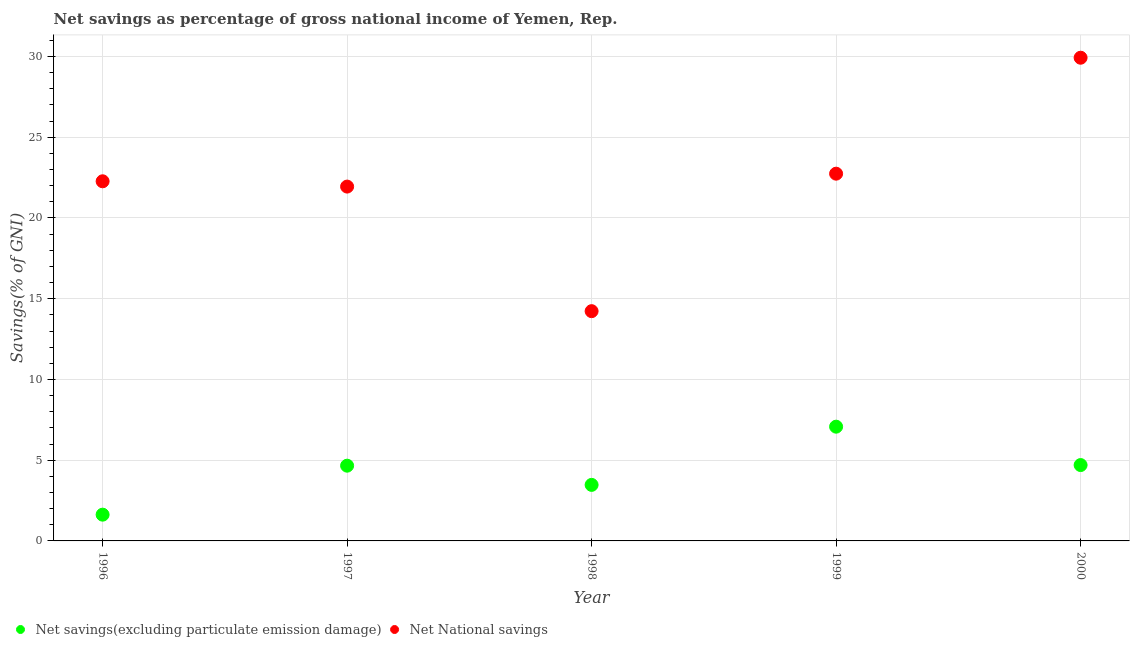Is the number of dotlines equal to the number of legend labels?
Make the answer very short. Yes. What is the net savings(excluding particulate emission damage) in 1998?
Provide a short and direct response. 3.47. Across all years, what is the maximum net savings(excluding particulate emission damage)?
Your answer should be very brief. 7.08. Across all years, what is the minimum net national savings?
Your answer should be compact. 14.23. In which year was the net savings(excluding particulate emission damage) maximum?
Provide a succinct answer. 1999. In which year was the net savings(excluding particulate emission damage) minimum?
Offer a terse response. 1996. What is the total net national savings in the graph?
Give a very brief answer. 111.11. What is the difference between the net national savings in 1996 and that in 1997?
Your response must be concise. 0.33. What is the difference between the net national savings in 1996 and the net savings(excluding particulate emission damage) in 2000?
Make the answer very short. 17.57. What is the average net national savings per year?
Provide a succinct answer. 22.22. In the year 2000, what is the difference between the net savings(excluding particulate emission damage) and net national savings?
Offer a very short reply. -25.23. What is the ratio of the net national savings in 1998 to that in 2000?
Provide a succinct answer. 0.48. Is the net savings(excluding particulate emission damage) in 1996 less than that in 2000?
Make the answer very short. Yes. Is the difference between the net savings(excluding particulate emission damage) in 1998 and 2000 greater than the difference between the net national savings in 1998 and 2000?
Make the answer very short. Yes. What is the difference between the highest and the second highest net national savings?
Make the answer very short. 7.18. What is the difference between the highest and the lowest net national savings?
Keep it short and to the point. 15.7. In how many years, is the net national savings greater than the average net national savings taken over all years?
Offer a terse response. 3. Is the net national savings strictly greater than the net savings(excluding particulate emission damage) over the years?
Make the answer very short. Yes. What is the difference between two consecutive major ticks on the Y-axis?
Keep it short and to the point. 5. Are the values on the major ticks of Y-axis written in scientific E-notation?
Your response must be concise. No. Does the graph contain any zero values?
Offer a terse response. No. Does the graph contain grids?
Your response must be concise. Yes. Where does the legend appear in the graph?
Offer a very short reply. Bottom left. What is the title of the graph?
Ensure brevity in your answer.  Net savings as percentage of gross national income of Yemen, Rep. Does "By country of asylum" appear as one of the legend labels in the graph?
Your answer should be very brief. No. What is the label or title of the Y-axis?
Your response must be concise. Savings(% of GNI). What is the Savings(% of GNI) in Net savings(excluding particulate emission damage) in 1996?
Ensure brevity in your answer.  1.63. What is the Savings(% of GNI) of Net National savings in 1996?
Ensure brevity in your answer.  22.27. What is the Savings(% of GNI) in Net savings(excluding particulate emission damage) in 1997?
Offer a very short reply. 4.66. What is the Savings(% of GNI) in Net National savings in 1997?
Give a very brief answer. 21.94. What is the Savings(% of GNI) of Net savings(excluding particulate emission damage) in 1998?
Provide a short and direct response. 3.47. What is the Savings(% of GNI) in Net National savings in 1998?
Provide a short and direct response. 14.23. What is the Savings(% of GNI) of Net savings(excluding particulate emission damage) in 1999?
Make the answer very short. 7.08. What is the Savings(% of GNI) in Net National savings in 1999?
Provide a short and direct response. 22.74. What is the Savings(% of GNI) in Net savings(excluding particulate emission damage) in 2000?
Your answer should be very brief. 4.7. What is the Savings(% of GNI) in Net National savings in 2000?
Your answer should be very brief. 29.92. Across all years, what is the maximum Savings(% of GNI) of Net savings(excluding particulate emission damage)?
Offer a terse response. 7.08. Across all years, what is the maximum Savings(% of GNI) in Net National savings?
Give a very brief answer. 29.92. Across all years, what is the minimum Savings(% of GNI) of Net savings(excluding particulate emission damage)?
Make the answer very short. 1.63. Across all years, what is the minimum Savings(% of GNI) of Net National savings?
Your response must be concise. 14.23. What is the total Savings(% of GNI) in Net savings(excluding particulate emission damage) in the graph?
Your answer should be very brief. 21.53. What is the total Savings(% of GNI) in Net National savings in the graph?
Keep it short and to the point. 111.11. What is the difference between the Savings(% of GNI) in Net savings(excluding particulate emission damage) in 1996 and that in 1997?
Offer a terse response. -3.03. What is the difference between the Savings(% of GNI) of Net National savings in 1996 and that in 1997?
Provide a short and direct response. 0.33. What is the difference between the Savings(% of GNI) in Net savings(excluding particulate emission damage) in 1996 and that in 1998?
Offer a very short reply. -1.84. What is the difference between the Savings(% of GNI) of Net National savings in 1996 and that in 1998?
Your answer should be very brief. 8.04. What is the difference between the Savings(% of GNI) of Net savings(excluding particulate emission damage) in 1996 and that in 1999?
Make the answer very short. -5.45. What is the difference between the Savings(% of GNI) of Net National savings in 1996 and that in 1999?
Keep it short and to the point. -0.47. What is the difference between the Savings(% of GNI) in Net savings(excluding particulate emission damage) in 1996 and that in 2000?
Make the answer very short. -3.07. What is the difference between the Savings(% of GNI) in Net National savings in 1996 and that in 2000?
Your answer should be compact. -7.65. What is the difference between the Savings(% of GNI) of Net savings(excluding particulate emission damage) in 1997 and that in 1998?
Keep it short and to the point. 1.19. What is the difference between the Savings(% of GNI) of Net National savings in 1997 and that in 1998?
Make the answer very short. 7.71. What is the difference between the Savings(% of GNI) of Net savings(excluding particulate emission damage) in 1997 and that in 1999?
Provide a short and direct response. -2.42. What is the difference between the Savings(% of GNI) in Net National savings in 1997 and that in 1999?
Give a very brief answer. -0.8. What is the difference between the Savings(% of GNI) in Net savings(excluding particulate emission damage) in 1997 and that in 2000?
Your answer should be compact. -0.04. What is the difference between the Savings(% of GNI) in Net National savings in 1997 and that in 2000?
Offer a terse response. -7.98. What is the difference between the Savings(% of GNI) in Net savings(excluding particulate emission damage) in 1998 and that in 1999?
Your answer should be compact. -3.6. What is the difference between the Savings(% of GNI) in Net National savings in 1998 and that in 1999?
Your answer should be compact. -8.51. What is the difference between the Savings(% of GNI) of Net savings(excluding particulate emission damage) in 1998 and that in 2000?
Your response must be concise. -1.23. What is the difference between the Savings(% of GNI) in Net National savings in 1998 and that in 2000?
Offer a very short reply. -15.7. What is the difference between the Savings(% of GNI) of Net savings(excluding particulate emission damage) in 1999 and that in 2000?
Offer a terse response. 2.38. What is the difference between the Savings(% of GNI) of Net National savings in 1999 and that in 2000?
Your answer should be very brief. -7.18. What is the difference between the Savings(% of GNI) of Net savings(excluding particulate emission damage) in 1996 and the Savings(% of GNI) of Net National savings in 1997?
Your response must be concise. -20.32. What is the difference between the Savings(% of GNI) in Net savings(excluding particulate emission damage) in 1996 and the Savings(% of GNI) in Net National savings in 1998?
Your response must be concise. -12.6. What is the difference between the Savings(% of GNI) in Net savings(excluding particulate emission damage) in 1996 and the Savings(% of GNI) in Net National savings in 1999?
Make the answer very short. -21.12. What is the difference between the Savings(% of GNI) of Net savings(excluding particulate emission damage) in 1996 and the Savings(% of GNI) of Net National savings in 2000?
Your answer should be compact. -28.3. What is the difference between the Savings(% of GNI) in Net savings(excluding particulate emission damage) in 1997 and the Savings(% of GNI) in Net National savings in 1998?
Your answer should be compact. -9.57. What is the difference between the Savings(% of GNI) in Net savings(excluding particulate emission damage) in 1997 and the Savings(% of GNI) in Net National savings in 1999?
Provide a succinct answer. -18.08. What is the difference between the Savings(% of GNI) of Net savings(excluding particulate emission damage) in 1997 and the Savings(% of GNI) of Net National savings in 2000?
Provide a succinct answer. -25.26. What is the difference between the Savings(% of GNI) in Net savings(excluding particulate emission damage) in 1998 and the Savings(% of GNI) in Net National savings in 1999?
Provide a succinct answer. -19.27. What is the difference between the Savings(% of GNI) in Net savings(excluding particulate emission damage) in 1998 and the Savings(% of GNI) in Net National savings in 2000?
Provide a short and direct response. -26.45. What is the difference between the Savings(% of GNI) in Net savings(excluding particulate emission damage) in 1999 and the Savings(% of GNI) in Net National savings in 2000?
Offer a very short reply. -22.85. What is the average Savings(% of GNI) in Net savings(excluding particulate emission damage) per year?
Provide a short and direct response. 4.31. What is the average Savings(% of GNI) in Net National savings per year?
Your answer should be very brief. 22.22. In the year 1996, what is the difference between the Savings(% of GNI) of Net savings(excluding particulate emission damage) and Savings(% of GNI) of Net National savings?
Your answer should be compact. -20.65. In the year 1997, what is the difference between the Savings(% of GNI) of Net savings(excluding particulate emission damage) and Savings(% of GNI) of Net National savings?
Offer a very short reply. -17.28. In the year 1998, what is the difference between the Savings(% of GNI) in Net savings(excluding particulate emission damage) and Savings(% of GNI) in Net National savings?
Make the answer very short. -10.76. In the year 1999, what is the difference between the Savings(% of GNI) of Net savings(excluding particulate emission damage) and Savings(% of GNI) of Net National savings?
Your response must be concise. -15.67. In the year 2000, what is the difference between the Savings(% of GNI) of Net savings(excluding particulate emission damage) and Savings(% of GNI) of Net National savings?
Your response must be concise. -25.23. What is the ratio of the Savings(% of GNI) in Net savings(excluding particulate emission damage) in 1996 to that in 1997?
Your answer should be very brief. 0.35. What is the ratio of the Savings(% of GNI) in Net National savings in 1996 to that in 1997?
Your response must be concise. 1.01. What is the ratio of the Savings(% of GNI) of Net savings(excluding particulate emission damage) in 1996 to that in 1998?
Provide a succinct answer. 0.47. What is the ratio of the Savings(% of GNI) in Net National savings in 1996 to that in 1998?
Offer a very short reply. 1.57. What is the ratio of the Savings(% of GNI) of Net savings(excluding particulate emission damage) in 1996 to that in 1999?
Ensure brevity in your answer.  0.23. What is the ratio of the Savings(% of GNI) of Net National savings in 1996 to that in 1999?
Offer a very short reply. 0.98. What is the ratio of the Savings(% of GNI) of Net savings(excluding particulate emission damage) in 1996 to that in 2000?
Provide a short and direct response. 0.35. What is the ratio of the Savings(% of GNI) in Net National savings in 1996 to that in 2000?
Give a very brief answer. 0.74. What is the ratio of the Savings(% of GNI) in Net savings(excluding particulate emission damage) in 1997 to that in 1998?
Give a very brief answer. 1.34. What is the ratio of the Savings(% of GNI) of Net National savings in 1997 to that in 1998?
Offer a terse response. 1.54. What is the ratio of the Savings(% of GNI) in Net savings(excluding particulate emission damage) in 1997 to that in 1999?
Your answer should be compact. 0.66. What is the ratio of the Savings(% of GNI) in Net National savings in 1997 to that in 1999?
Your answer should be very brief. 0.96. What is the ratio of the Savings(% of GNI) of Net savings(excluding particulate emission damage) in 1997 to that in 2000?
Provide a short and direct response. 0.99. What is the ratio of the Savings(% of GNI) in Net National savings in 1997 to that in 2000?
Your answer should be compact. 0.73. What is the ratio of the Savings(% of GNI) in Net savings(excluding particulate emission damage) in 1998 to that in 1999?
Your response must be concise. 0.49. What is the ratio of the Savings(% of GNI) in Net National savings in 1998 to that in 1999?
Your response must be concise. 0.63. What is the ratio of the Savings(% of GNI) in Net savings(excluding particulate emission damage) in 1998 to that in 2000?
Keep it short and to the point. 0.74. What is the ratio of the Savings(% of GNI) in Net National savings in 1998 to that in 2000?
Offer a terse response. 0.48. What is the ratio of the Savings(% of GNI) of Net savings(excluding particulate emission damage) in 1999 to that in 2000?
Ensure brevity in your answer.  1.51. What is the ratio of the Savings(% of GNI) in Net National savings in 1999 to that in 2000?
Provide a short and direct response. 0.76. What is the difference between the highest and the second highest Savings(% of GNI) in Net savings(excluding particulate emission damage)?
Provide a succinct answer. 2.38. What is the difference between the highest and the second highest Savings(% of GNI) of Net National savings?
Ensure brevity in your answer.  7.18. What is the difference between the highest and the lowest Savings(% of GNI) of Net savings(excluding particulate emission damage)?
Ensure brevity in your answer.  5.45. What is the difference between the highest and the lowest Savings(% of GNI) of Net National savings?
Your answer should be very brief. 15.7. 